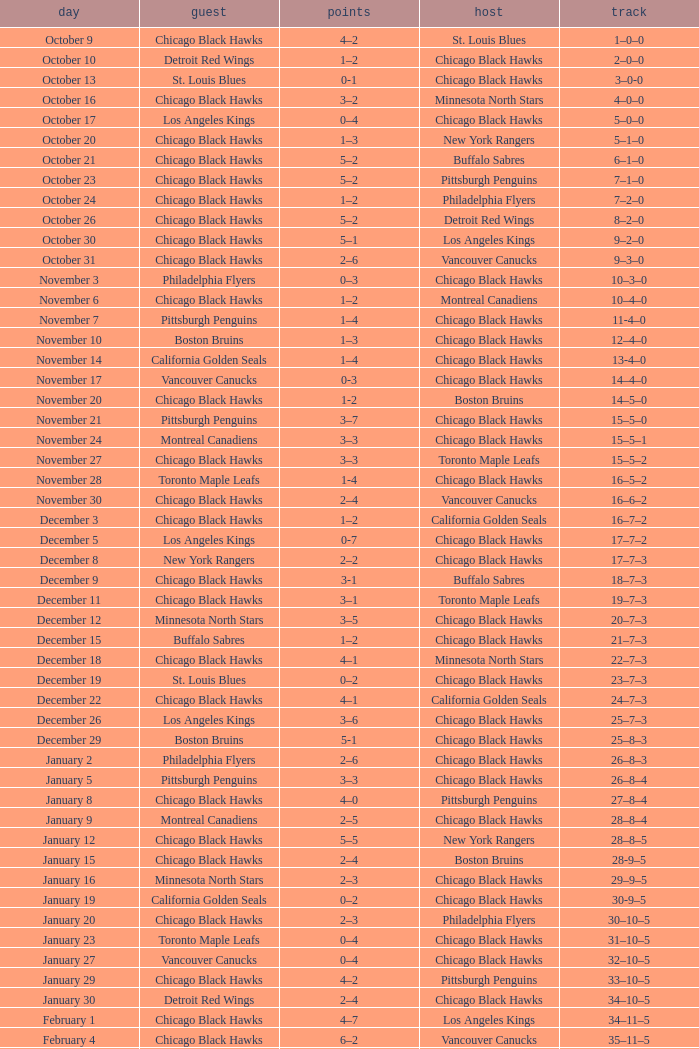What is the Score of the Chicago Black Hawks Home game with the Visiting Vancouver Canucks on November 17? 0-3. Could you parse the entire table as a dict? {'header': ['day', 'guest', 'points', 'host', 'track'], 'rows': [['October 9', 'Chicago Black Hawks', '4–2', 'St. Louis Blues', '1–0–0'], ['October 10', 'Detroit Red Wings', '1–2', 'Chicago Black Hawks', '2–0–0'], ['October 13', 'St. Louis Blues', '0-1', 'Chicago Black Hawks', '3–0-0'], ['October 16', 'Chicago Black Hawks', '3–2', 'Minnesota North Stars', '4–0–0'], ['October 17', 'Los Angeles Kings', '0–4', 'Chicago Black Hawks', '5–0–0'], ['October 20', 'Chicago Black Hawks', '1–3', 'New York Rangers', '5–1–0'], ['October 21', 'Chicago Black Hawks', '5–2', 'Buffalo Sabres', '6–1–0'], ['October 23', 'Chicago Black Hawks', '5–2', 'Pittsburgh Penguins', '7–1–0'], ['October 24', 'Chicago Black Hawks', '1–2', 'Philadelphia Flyers', '7–2–0'], ['October 26', 'Chicago Black Hawks', '5–2', 'Detroit Red Wings', '8–2–0'], ['October 30', 'Chicago Black Hawks', '5–1', 'Los Angeles Kings', '9–2–0'], ['October 31', 'Chicago Black Hawks', '2–6', 'Vancouver Canucks', '9–3–0'], ['November 3', 'Philadelphia Flyers', '0–3', 'Chicago Black Hawks', '10–3–0'], ['November 6', 'Chicago Black Hawks', '1–2', 'Montreal Canadiens', '10–4–0'], ['November 7', 'Pittsburgh Penguins', '1–4', 'Chicago Black Hawks', '11-4–0'], ['November 10', 'Boston Bruins', '1–3', 'Chicago Black Hawks', '12–4–0'], ['November 14', 'California Golden Seals', '1–4', 'Chicago Black Hawks', '13-4–0'], ['November 17', 'Vancouver Canucks', '0-3', 'Chicago Black Hawks', '14–4–0'], ['November 20', 'Chicago Black Hawks', '1-2', 'Boston Bruins', '14–5–0'], ['November 21', 'Pittsburgh Penguins', '3–7', 'Chicago Black Hawks', '15–5–0'], ['November 24', 'Montreal Canadiens', '3–3', 'Chicago Black Hawks', '15–5–1'], ['November 27', 'Chicago Black Hawks', '3–3', 'Toronto Maple Leafs', '15–5–2'], ['November 28', 'Toronto Maple Leafs', '1-4', 'Chicago Black Hawks', '16–5–2'], ['November 30', 'Chicago Black Hawks', '2–4', 'Vancouver Canucks', '16–6–2'], ['December 3', 'Chicago Black Hawks', '1–2', 'California Golden Seals', '16–7–2'], ['December 5', 'Los Angeles Kings', '0-7', 'Chicago Black Hawks', '17–7–2'], ['December 8', 'New York Rangers', '2–2', 'Chicago Black Hawks', '17–7–3'], ['December 9', 'Chicago Black Hawks', '3-1', 'Buffalo Sabres', '18–7–3'], ['December 11', 'Chicago Black Hawks', '3–1', 'Toronto Maple Leafs', '19–7–3'], ['December 12', 'Minnesota North Stars', '3–5', 'Chicago Black Hawks', '20–7–3'], ['December 15', 'Buffalo Sabres', '1–2', 'Chicago Black Hawks', '21–7–3'], ['December 18', 'Chicago Black Hawks', '4–1', 'Minnesota North Stars', '22–7–3'], ['December 19', 'St. Louis Blues', '0–2', 'Chicago Black Hawks', '23–7–3'], ['December 22', 'Chicago Black Hawks', '4–1', 'California Golden Seals', '24–7–3'], ['December 26', 'Los Angeles Kings', '3–6', 'Chicago Black Hawks', '25–7–3'], ['December 29', 'Boston Bruins', '5-1', 'Chicago Black Hawks', '25–8–3'], ['January 2', 'Philadelphia Flyers', '2–6', 'Chicago Black Hawks', '26–8–3'], ['January 5', 'Pittsburgh Penguins', '3–3', 'Chicago Black Hawks', '26–8–4'], ['January 8', 'Chicago Black Hawks', '4–0', 'Pittsburgh Penguins', '27–8–4'], ['January 9', 'Montreal Canadiens', '2–5', 'Chicago Black Hawks', '28–8–4'], ['January 12', 'Chicago Black Hawks', '5–5', 'New York Rangers', '28–8–5'], ['January 15', 'Chicago Black Hawks', '2–4', 'Boston Bruins', '28-9–5'], ['January 16', 'Minnesota North Stars', '2–3', 'Chicago Black Hawks', '29–9–5'], ['January 19', 'California Golden Seals', '0–2', 'Chicago Black Hawks', '30-9–5'], ['January 20', 'Chicago Black Hawks', '2–3', 'Philadelphia Flyers', '30–10–5'], ['January 23', 'Toronto Maple Leafs', '0–4', 'Chicago Black Hawks', '31–10–5'], ['January 27', 'Vancouver Canucks', '0–4', 'Chicago Black Hawks', '32–10–5'], ['January 29', 'Chicago Black Hawks', '4–2', 'Pittsburgh Penguins', '33–10–5'], ['January 30', 'Detroit Red Wings', '2–4', 'Chicago Black Hawks', '34–10–5'], ['February 1', 'Chicago Black Hawks', '4–7', 'Los Angeles Kings', '34–11–5'], ['February 4', 'Chicago Black Hawks', '6–2', 'Vancouver Canucks', '35–11–5'], ['February 6', 'Minnesota North Stars', '0–5', 'Chicago Black Hawks', '36–11–5'], ['February 9', 'Chicago Black Hawks', '1–4', 'New York Rangers', '36–12–5'], ['February 10', 'Chicago Black Hawks', '1–7', 'Montreal Canadiens', '36–13–5'], ['February 12', 'Chicago Black Hawks', '3-3', 'Detroit Red Wings', '36–13–6'], ['February 13', 'Toronto Maple Leafs', '1–3', 'Chicago Black Hawks', '37–13–6'], ['February 15', 'Chicago Black Hawks', '3–2', 'St. Louis Blues', '38–13–6'], ['February 16', 'Philadelphia Flyers', '3–3', 'Chicago Black Hawks', '38–13–7'], ['February 20', 'Boston Bruins', '3–1', 'Chicago Black Hawks', '38–14–7'], ['February 23', 'Buffalo Sabres', '2–1', 'Chicago Black Hawks', '38–15–7'], ['February 24', 'Chicago Black Hawks', '3–5', 'Buffalo Sabres', '38–16–7'], ['February 26', 'California Golden Seals', '0–3', 'Chicago Black Hawks', '39–16–7'], ['February 27', 'Vancouver Canucks', '3–3', 'Chicago Black Hawks', '39–16–8'], ['March 1', 'Chicago Black Hawks', '6–4', 'Los Angeles Kings', '40–16–8'], ['March 3', 'Chicago Black Hawks', '4-4', 'California Golden Seals', '40–16–9'], ['March 5', 'Chicago Black Hawks', '1–2', 'Minnesota North Stars', '40–17–9'], ['March 8', 'Chicago Black Hawks', '3–3', 'New York Rangers', '40–17–10'], ['March 11', 'Chicago Black Hawks', '1–1', 'Montreal Canadiens', '40–17–11'], ['March 12', 'Chicago Black Hawks', '3–2', 'Detroit Red Wings', '41–17–11'], ['March 15', 'New York Rangers', '1–3', 'Chicago Black Hawks', '42–17–11'], ['March 18', 'Chicago Black Hawks', '2–2', 'Toronto Maple Leafs', '42–17–12'], ['March 19', 'Buffalo Sabres', '3–3', 'Chicago Black Hawks', '42–17-13'], ['March 23', 'Chicago Black Hawks', '4–2', 'Philadelphia Flyers', '43–17–13'], ['March 25', 'Chicago Black Hawks', '5–5', 'Boston Bruins', '43–17–14'], ['March 26', 'St. Louis Blues', '0–4', 'Chicago Black Hawks', '44–17–14'], ['March 29', 'Montreal Canadiens', '5–5', 'Chicago Black Hawks', '44–17–15'], ['April 1', 'Chicago Black Hawks', '2–0', 'St. Louis Blues', '45–17–15'], ['April 2', 'Detroit Red Wings', '1–6', 'Chicago Black Hawks', '46-17–15']]} 